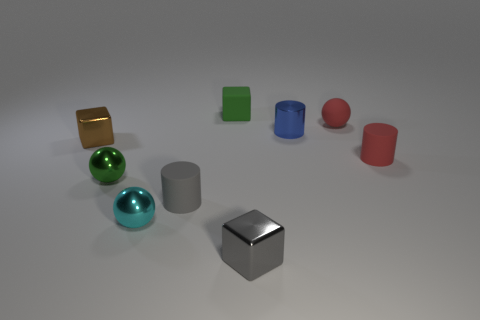What is the size of the green thing that is made of the same material as the tiny blue object? The green object appears to be a sphere of small size, comparable to the tiny blue sphere next to it, suggesting that they share not only material properties but also a similar size scale. 